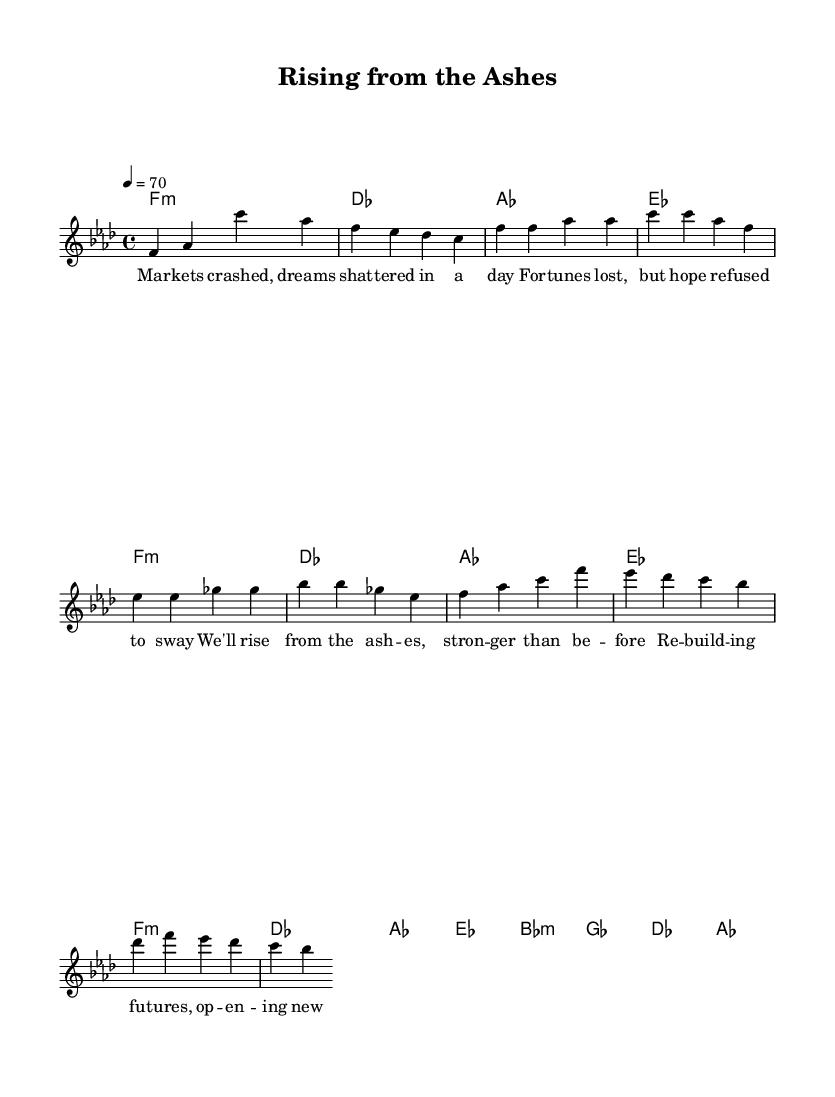What is the key signature of this music? The key signature is indicated by the absence of accidentals on the staff. Since the piece is in F minor, it typically contains four flats: B♭, E♭, A♭, and D♭. This aligns with the key signature that appears at the beginning of the piece.
Answer: F minor What is the time signature of this music? The time signature is found at the beginning of the score, presented as a fraction. This piece shows a 4 over 4, indicating that there are four beats in each measure and that the quarter note gets one beat.
Answer: 4/4 What is the tempo marking of the piece? The tempo marking is given in beats per minute. In this score, it mentions "4 = 70," meaning that there are 70 beats per minute for the quarter note.
Answer: 70 How many measures are in the chorus section? To find the number of measures in the chorus, we count the written musical units in that section. The chorus consists of eight measures as indicated by the distinct bar lines separating each measure.
Answer: 8 What chord is played at the beginning of the introduction? The introduction starts with a chord represented by the chord names above the staff. The first chord is labeled as 'F:min', indicating that it is an F minor chord.
Answer: F:min What theme is expressed in the lyrics? Upon reviewing the lyrics, it’s clear that the theme revolves around resilience and hope following financial hardship. The lyrics explicitly mention crashing markets and rebuilding futures, showing the struggle and recovery process.
Answer: Resilience How does the melody of the verse compare to the chorus? By comparing the melody lines of the verse and chorus, it is evident that the verse features a more subdued and reflective melody, while the chorus has a stronger and uplifting melodic progression, signifying hope and strength.
Answer: Uneven 